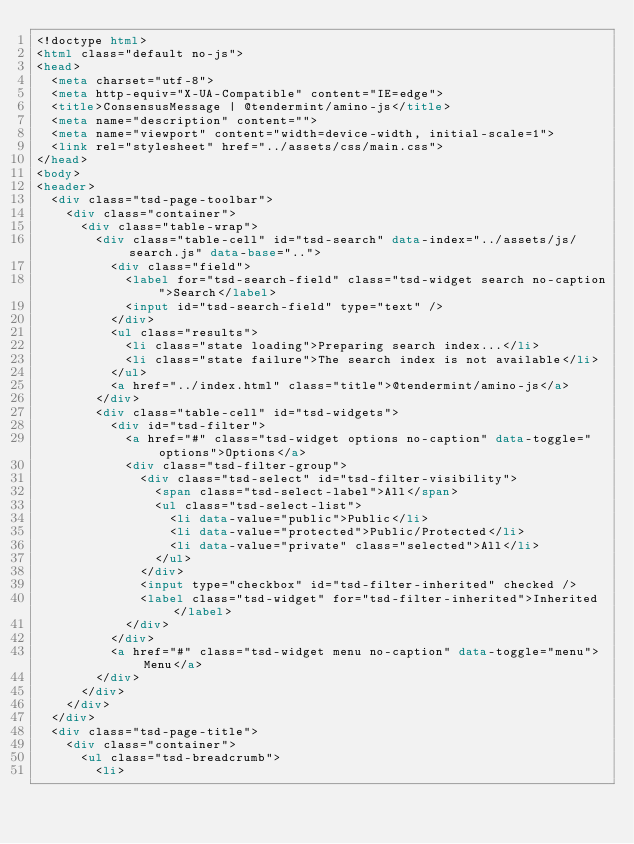Convert code to text. <code><loc_0><loc_0><loc_500><loc_500><_HTML_><!doctype html>
<html class="default no-js">
<head>
	<meta charset="utf-8">
	<meta http-equiv="X-UA-Compatible" content="IE=edge">
	<title>ConsensusMessage | @tendermint/amino-js</title>
	<meta name="description" content="">
	<meta name="viewport" content="width=device-width, initial-scale=1">
	<link rel="stylesheet" href="../assets/css/main.css">
</head>
<body>
<header>
	<div class="tsd-page-toolbar">
		<div class="container">
			<div class="table-wrap">
				<div class="table-cell" id="tsd-search" data-index="../assets/js/search.js" data-base="..">
					<div class="field">
						<label for="tsd-search-field" class="tsd-widget search no-caption">Search</label>
						<input id="tsd-search-field" type="text" />
					</div>
					<ul class="results">
						<li class="state loading">Preparing search index...</li>
						<li class="state failure">The search index is not available</li>
					</ul>
					<a href="../index.html" class="title">@tendermint/amino-js</a>
				</div>
				<div class="table-cell" id="tsd-widgets">
					<div id="tsd-filter">
						<a href="#" class="tsd-widget options no-caption" data-toggle="options">Options</a>
						<div class="tsd-filter-group">
							<div class="tsd-select" id="tsd-filter-visibility">
								<span class="tsd-select-label">All</span>
								<ul class="tsd-select-list">
									<li data-value="public">Public</li>
									<li data-value="protected">Public/Protected</li>
									<li data-value="private" class="selected">All</li>
								</ul>
							</div>
							<input type="checkbox" id="tsd-filter-inherited" checked />
							<label class="tsd-widget" for="tsd-filter-inherited">Inherited</label>
						</div>
					</div>
					<a href="#" class="tsd-widget menu no-caption" data-toggle="menu">Menu</a>
				</div>
			</div>
		</div>
	</div>
	<div class="tsd-page-title">
		<div class="container">
			<ul class="tsd-breadcrumb">
				<li></code> 